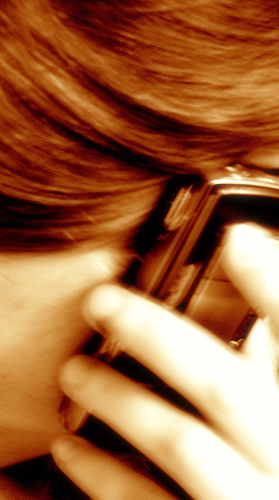<image>
Is there a phone to the left of the cheek? No. The phone is not to the left of the cheek. From this viewpoint, they have a different horizontal relationship. 